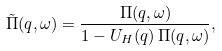<formula> <loc_0><loc_0><loc_500><loc_500>\tilde { \Pi } ( q , \omega ) = \frac { \Pi ( q , \omega ) } { 1 - U _ { H } ( q ) \, \Pi ( q , \omega ) } ,</formula> 